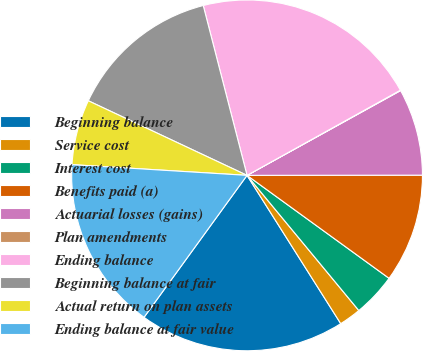Convert chart to OTSL. <chart><loc_0><loc_0><loc_500><loc_500><pie_chart><fcel>Beginning balance<fcel>Service cost<fcel>Interest cost<fcel>Benefits paid (a)<fcel>Actuarial losses (gains)<fcel>Plan amendments<fcel>Ending balance<fcel>Beginning balance at fair<fcel>Actual return on plan assets<fcel>Ending balance at fair value<nl><fcel>18.96%<fcel>2.03%<fcel>4.02%<fcel>10.0%<fcel>8.01%<fcel>0.04%<fcel>20.95%<fcel>13.99%<fcel>6.02%<fcel>15.98%<nl></chart> 